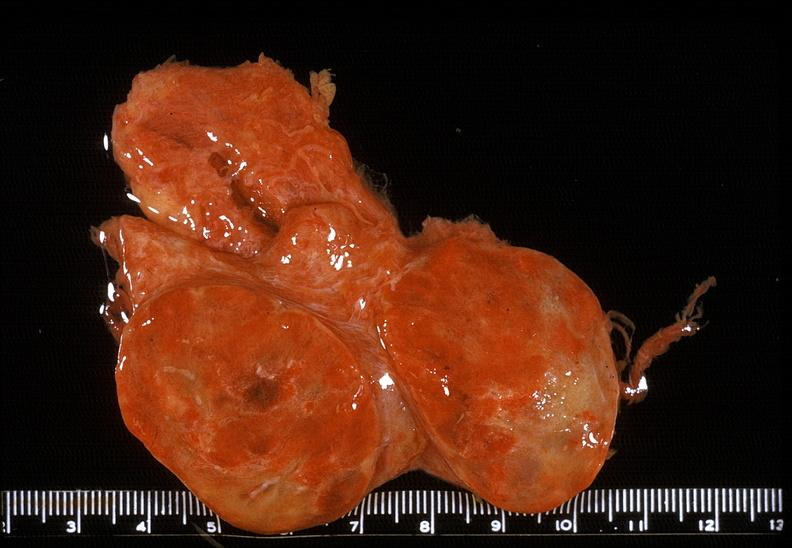s retroperitoneal leiomyosarcoma present?
Answer the question using a single word or phrase. No 